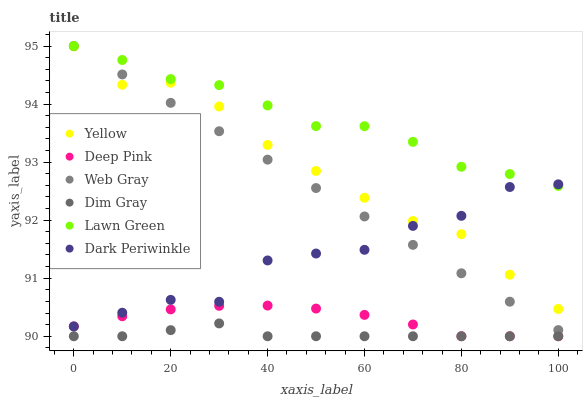Does Dim Gray have the minimum area under the curve?
Answer yes or no. Yes. Does Lawn Green have the maximum area under the curve?
Answer yes or no. Yes. Does Yellow have the minimum area under the curve?
Answer yes or no. No. Does Yellow have the maximum area under the curve?
Answer yes or no. No. Is Web Gray the smoothest?
Answer yes or no. Yes. Is Dark Periwinkle the roughest?
Answer yes or no. Yes. Is Dim Gray the smoothest?
Answer yes or no. No. Is Dim Gray the roughest?
Answer yes or no. No. Does Dim Gray have the lowest value?
Answer yes or no. Yes. Does Yellow have the lowest value?
Answer yes or no. No. Does Web Gray have the highest value?
Answer yes or no. Yes. Does Yellow have the highest value?
Answer yes or no. No. Is Yellow less than Lawn Green?
Answer yes or no. Yes. Is Lawn Green greater than Yellow?
Answer yes or no. Yes. Does Web Gray intersect Yellow?
Answer yes or no. Yes. Is Web Gray less than Yellow?
Answer yes or no. No. Is Web Gray greater than Yellow?
Answer yes or no. No. Does Yellow intersect Lawn Green?
Answer yes or no. No. 